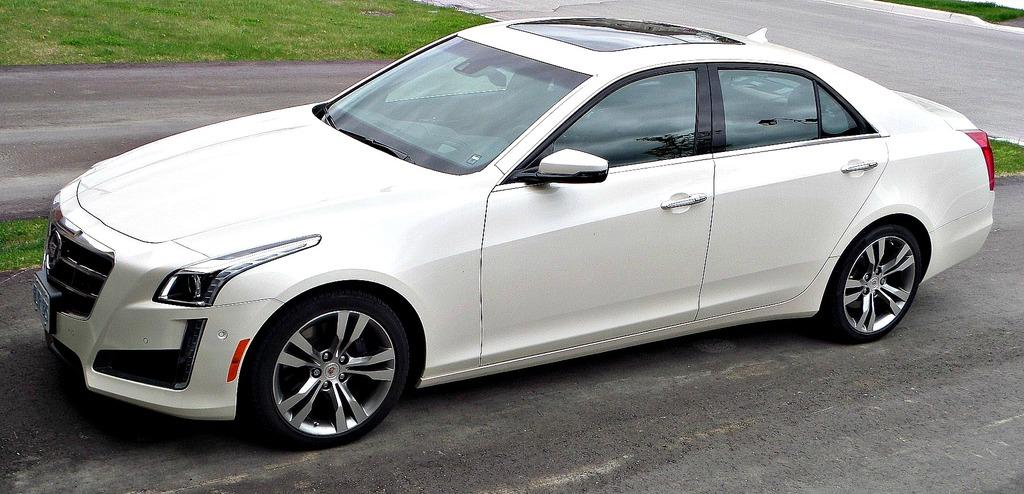What color is the car in the image? The car in the image is white. Where is the car located in the image? The car is on the road in the image. What can be seen in the background of the image? There is grass visible in the background of the image. How many cats are sitting on the hood of the car in the image? There are no cats present in the image; it only features a white color car on the road with grass visible in the background. 